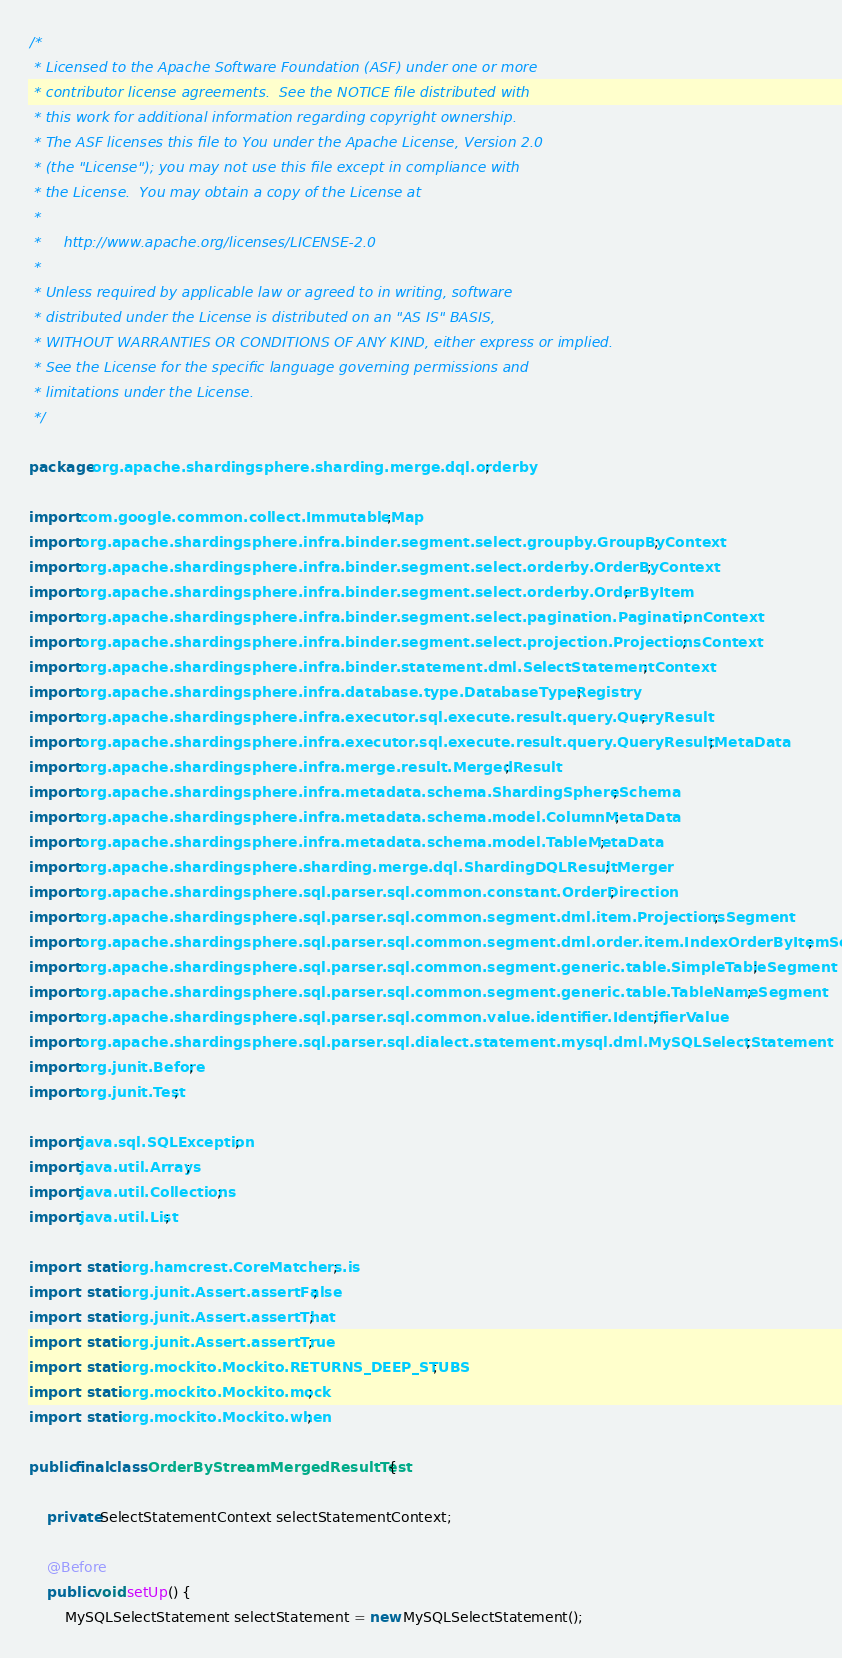Convert code to text. <code><loc_0><loc_0><loc_500><loc_500><_Java_>/*
 * Licensed to the Apache Software Foundation (ASF) under one or more
 * contributor license agreements.  See the NOTICE file distributed with
 * this work for additional information regarding copyright ownership.
 * The ASF licenses this file to You under the Apache License, Version 2.0
 * (the "License"); you may not use this file except in compliance with
 * the License.  You may obtain a copy of the License at
 *
 *     http://www.apache.org/licenses/LICENSE-2.0
 *
 * Unless required by applicable law or agreed to in writing, software
 * distributed under the License is distributed on an "AS IS" BASIS,
 * WITHOUT WARRANTIES OR CONDITIONS OF ANY KIND, either express or implied.
 * See the License for the specific language governing permissions and
 * limitations under the License.
 */

package org.apache.shardingsphere.sharding.merge.dql.orderby;

import com.google.common.collect.ImmutableMap;
import org.apache.shardingsphere.infra.binder.segment.select.groupby.GroupByContext;
import org.apache.shardingsphere.infra.binder.segment.select.orderby.OrderByContext;
import org.apache.shardingsphere.infra.binder.segment.select.orderby.OrderByItem;
import org.apache.shardingsphere.infra.binder.segment.select.pagination.PaginationContext;
import org.apache.shardingsphere.infra.binder.segment.select.projection.ProjectionsContext;
import org.apache.shardingsphere.infra.binder.statement.dml.SelectStatementContext;
import org.apache.shardingsphere.infra.database.type.DatabaseTypeRegistry;
import org.apache.shardingsphere.infra.executor.sql.execute.result.query.QueryResult;
import org.apache.shardingsphere.infra.executor.sql.execute.result.query.QueryResultMetaData;
import org.apache.shardingsphere.infra.merge.result.MergedResult;
import org.apache.shardingsphere.infra.metadata.schema.ShardingSphereSchema;
import org.apache.shardingsphere.infra.metadata.schema.model.ColumnMetaData;
import org.apache.shardingsphere.infra.metadata.schema.model.TableMetaData;
import org.apache.shardingsphere.sharding.merge.dql.ShardingDQLResultMerger;
import org.apache.shardingsphere.sql.parser.sql.common.constant.OrderDirection;
import org.apache.shardingsphere.sql.parser.sql.common.segment.dml.item.ProjectionsSegment;
import org.apache.shardingsphere.sql.parser.sql.common.segment.dml.order.item.IndexOrderByItemSegment;
import org.apache.shardingsphere.sql.parser.sql.common.segment.generic.table.SimpleTableSegment;
import org.apache.shardingsphere.sql.parser.sql.common.segment.generic.table.TableNameSegment;
import org.apache.shardingsphere.sql.parser.sql.common.value.identifier.IdentifierValue;
import org.apache.shardingsphere.sql.parser.sql.dialect.statement.mysql.dml.MySQLSelectStatement;
import org.junit.Before;
import org.junit.Test;

import java.sql.SQLException;
import java.util.Arrays;
import java.util.Collections;
import java.util.List;

import static org.hamcrest.CoreMatchers.is;
import static org.junit.Assert.assertFalse;
import static org.junit.Assert.assertThat;
import static org.junit.Assert.assertTrue;
import static org.mockito.Mockito.RETURNS_DEEP_STUBS;
import static org.mockito.Mockito.mock;
import static org.mockito.Mockito.when;

public final class OrderByStreamMergedResultTest {
    
    private SelectStatementContext selectStatementContext;
    
    @Before
    public void setUp() {
        MySQLSelectStatement selectStatement = new MySQLSelectStatement();</code> 